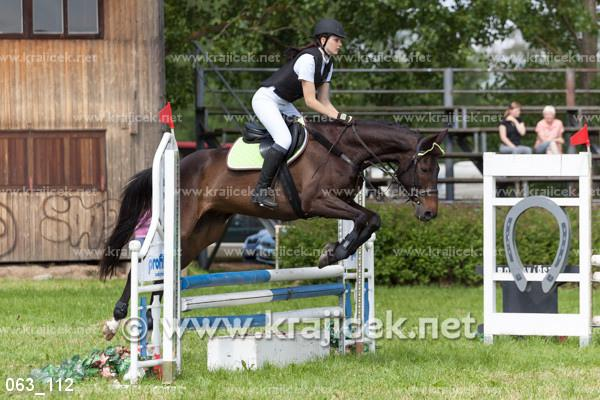What kind of horseback riding style is this? equestrian 